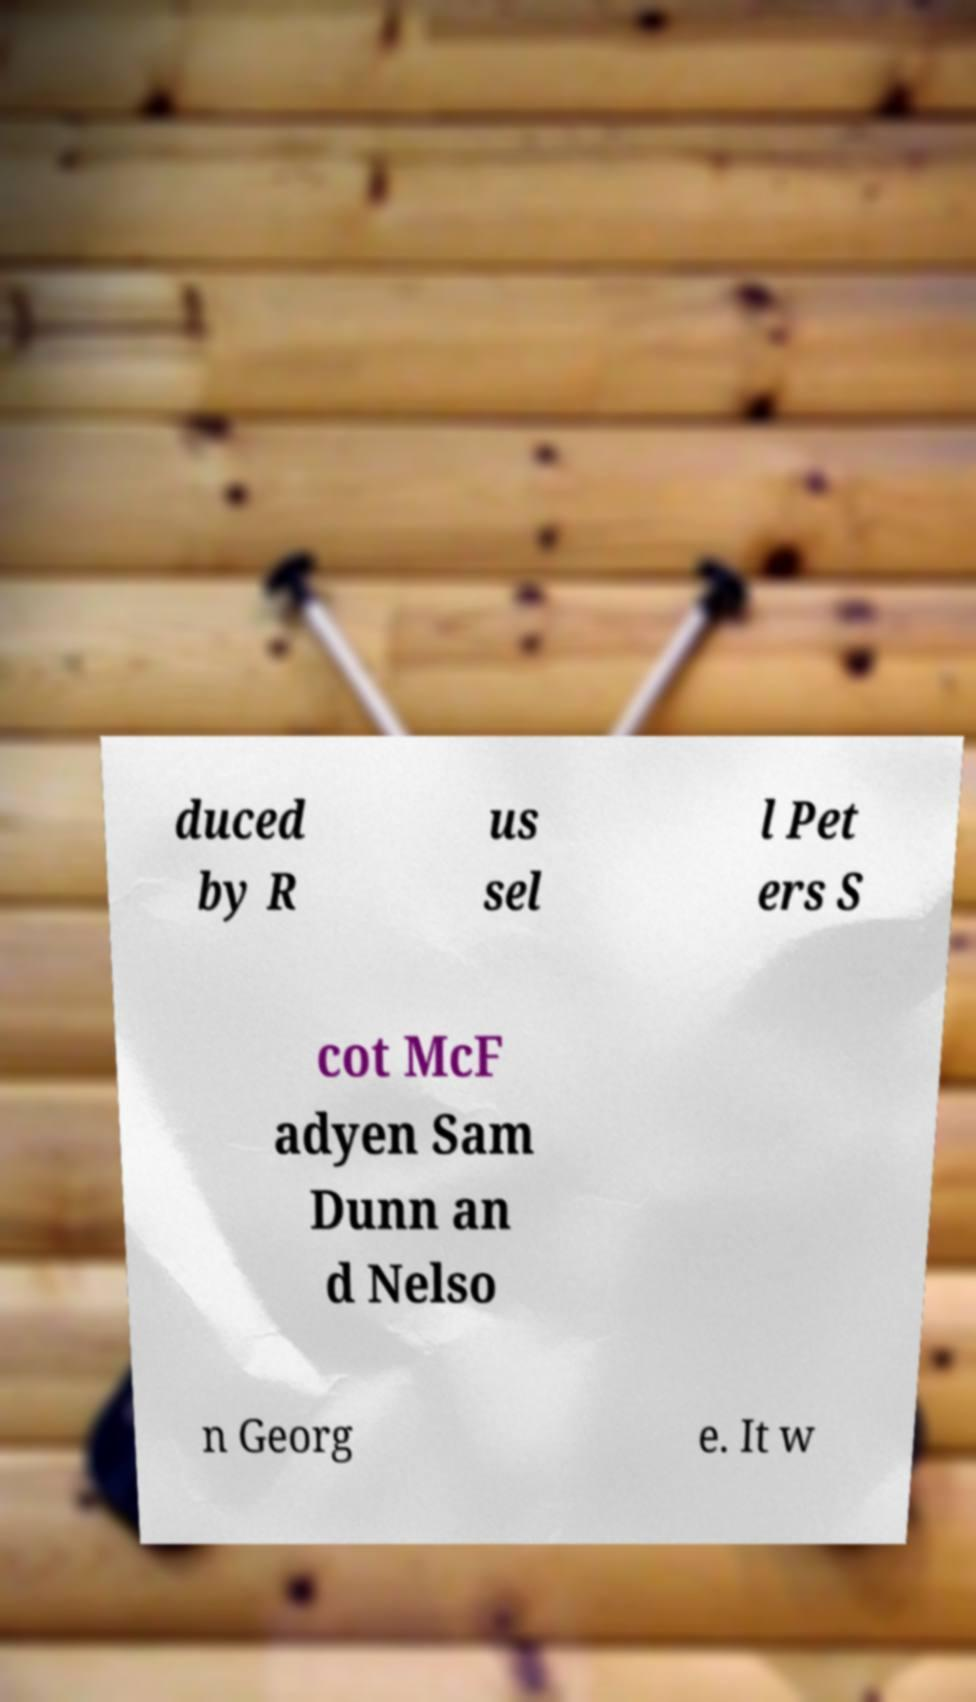Could you assist in decoding the text presented in this image and type it out clearly? duced by R us sel l Pet ers S cot McF adyen Sam Dunn an d Nelso n Georg e. It w 